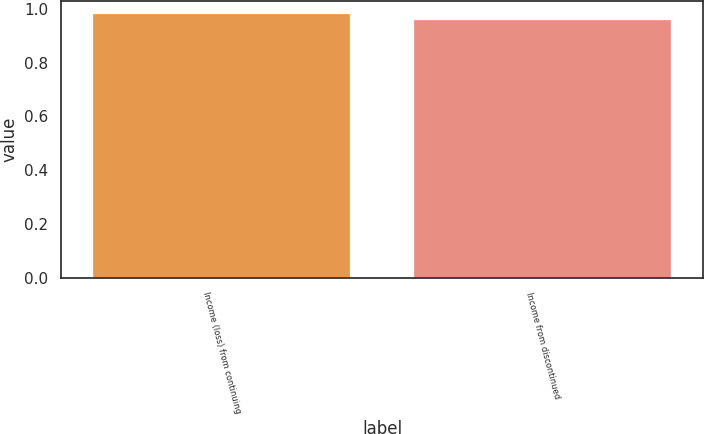Convert chart. <chart><loc_0><loc_0><loc_500><loc_500><bar_chart><fcel>Income (loss) from continuing<fcel>Income from discontinued<nl><fcel>0.98<fcel>0.96<nl></chart> 